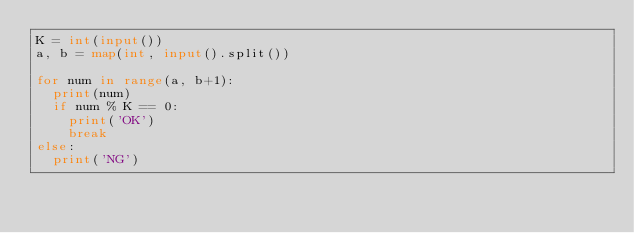<code> <loc_0><loc_0><loc_500><loc_500><_Python_>K = int(input())
a, b = map(int, input().split())

for num in range(a, b+1):
  print(num)
  if num % K == 0:
    print('OK')
    break
else:
  print('NG')
</code> 